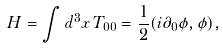Convert formula to latex. <formula><loc_0><loc_0><loc_500><loc_500>H = \int d ^ { 3 } x \, T _ { 0 0 } = \frac { 1 } { 2 } ( i \partial _ { 0 } \phi , \phi ) ,</formula> 